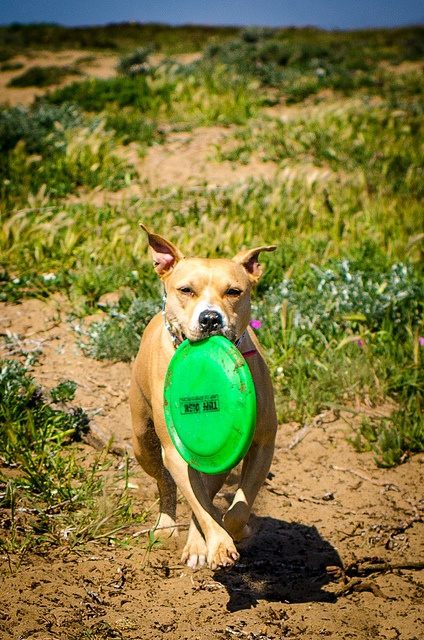Describe the objects in this image and their specific colors. I can see dog in blue, lime, tan, and olive tones and frisbee in blue, lime, green, and darkgreen tones in this image. 